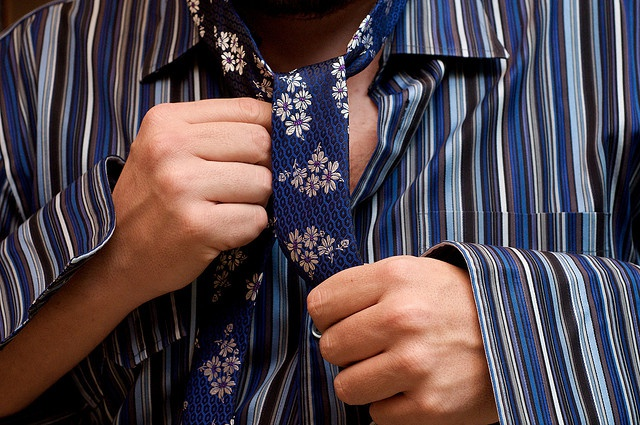Describe the objects in this image and their specific colors. I can see people in black, navy, maroon, gray, and tan tones and tie in black, navy, and gray tones in this image. 